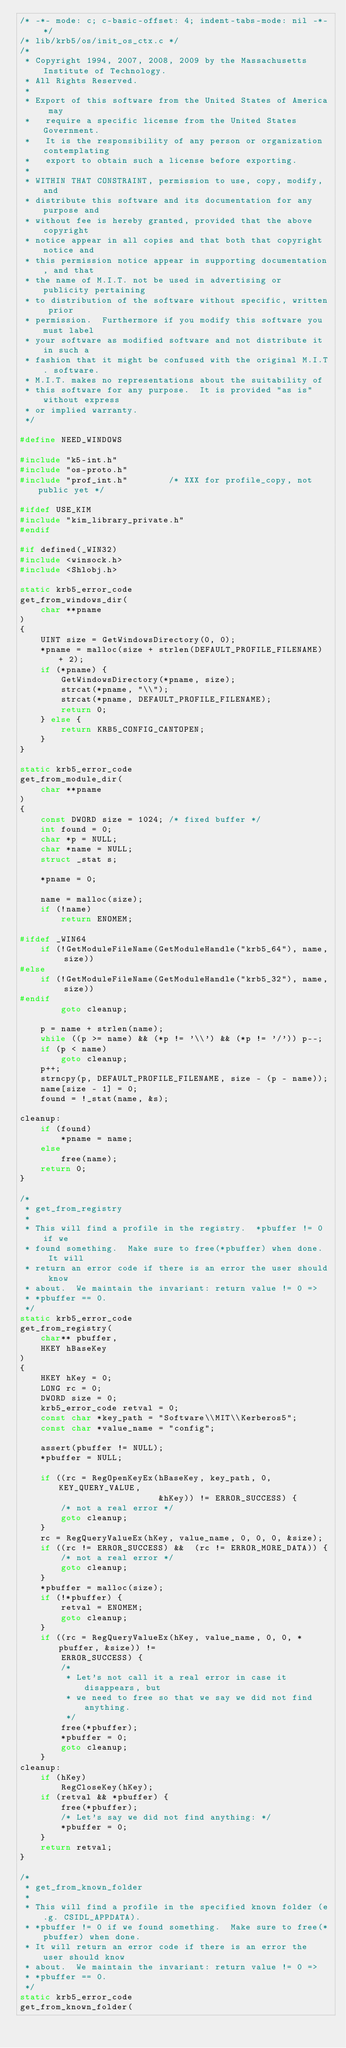Convert code to text. <code><loc_0><loc_0><loc_500><loc_500><_C_>/* -*- mode: c; c-basic-offset: 4; indent-tabs-mode: nil -*- */
/* lib/krb5/os/init_os_ctx.c */
/*
 * Copyright 1994, 2007, 2008, 2009 by the Massachusetts Institute of Technology.
 * All Rights Reserved.
 *
 * Export of this software from the United States of America may
 *   require a specific license from the United States Government.
 *   It is the responsibility of any person or organization contemplating
 *   export to obtain such a license before exporting.
 *
 * WITHIN THAT CONSTRAINT, permission to use, copy, modify, and
 * distribute this software and its documentation for any purpose and
 * without fee is hereby granted, provided that the above copyright
 * notice appear in all copies and that both that copyright notice and
 * this permission notice appear in supporting documentation, and that
 * the name of M.I.T. not be used in advertising or publicity pertaining
 * to distribution of the software without specific, written prior
 * permission.  Furthermore if you modify this software you must label
 * your software as modified software and not distribute it in such a
 * fashion that it might be confused with the original M.I.T. software.
 * M.I.T. makes no representations about the suitability of
 * this software for any purpose.  It is provided "as is" without express
 * or implied warranty.
 */

#define NEED_WINDOWS

#include "k5-int.h"
#include "os-proto.h"
#include "prof_int.h"        /* XXX for profile_copy, not public yet */

#ifdef USE_KIM
#include "kim_library_private.h"
#endif

#if defined(_WIN32)
#include <winsock.h>
#include <Shlobj.h>

static krb5_error_code
get_from_windows_dir(
    char **pname
)
{
    UINT size = GetWindowsDirectory(0, 0);
    *pname = malloc(size + strlen(DEFAULT_PROFILE_FILENAME) + 2);
    if (*pname) {
        GetWindowsDirectory(*pname, size);
        strcat(*pname, "\\");
        strcat(*pname, DEFAULT_PROFILE_FILENAME);
        return 0;
    } else {
        return KRB5_CONFIG_CANTOPEN;
    }
}

static krb5_error_code
get_from_module_dir(
    char **pname
)
{
    const DWORD size = 1024; /* fixed buffer */
    int found = 0;
    char *p = NULL;
    char *name = NULL;
    struct _stat s;

    *pname = 0;

    name = malloc(size);
    if (!name)
        return ENOMEM;

#ifdef _WIN64
    if (!GetModuleFileName(GetModuleHandle("krb5_64"), name, size))
#else
    if (!GetModuleFileName(GetModuleHandle("krb5_32"), name, size))
#endif
        goto cleanup;

    p = name + strlen(name);
    while ((p >= name) && (*p != '\\') && (*p != '/')) p--;
    if (p < name)
        goto cleanup;
    p++;
    strncpy(p, DEFAULT_PROFILE_FILENAME, size - (p - name));
    name[size - 1] = 0;
    found = !_stat(name, &s);

cleanup:
    if (found)
        *pname = name;
    else
        free(name);
    return 0;
}

/*
 * get_from_registry
 *
 * This will find a profile in the registry.  *pbuffer != 0 if we
 * found something.  Make sure to free(*pbuffer) when done.  It will
 * return an error code if there is an error the user should know
 * about.  We maintain the invariant: return value != 0 =>
 * *pbuffer == 0.
 */
static krb5_error_code
get_from_registry(
    char** pbuffer,
    HKEY hBaseKey
)
{
    HKEY hKey = 0;
    LONG rc = 0;
    DWORD size = 0;
    krb5_error_code retval = 0;
    const char *key_path = "Software\\MIT\\Kerberos5";
    const char *value_name = "config";

    assert(pbuffer != NULL);
    *pbuffer = NULL;

    if ((rc = RegOpenKeyEx(hBaseKey, key_path, 0, KEY_QUERY_VALUE,
                           &hKey)) != ERROR_SUCCESS) {
        /* not a real error */
        goto cleanup;
    }
    rc = RegQueryValueEx(hKey, value_name, 0, 0, 0, &size);
    if ((rc != ERROR_SUCCESS) &&  (rc != ERROR_MORE_DATA)) {
        /* not a real error */
        goto cleanup;
    }
    *pbuffer = malloc(size);
    if (!*pbuffer) {
        retval = ENOMEM;
        goto cleanup;
    }
    if ((rc = RegQueryValueEx(hKey, value_name, 0, 0, *pbuffer, &size)) !=
        ERROR_SUCCESS) {
        /*
         * Let's not call it a real error in case it disappears, but
         * we need to free so that we say we did not find anything.
         */
        free(*pbuffer);
        *pbuffer = 0;
        goto cleanup;
    }
cleanup:
    if (hKey)
        RegCloseKey(hKey);
    if (retval && *pbuffer) {
        free(*pbuffer);
        /* Let's say we did not find anything: */
        *pbuffer = 0;
    }
    return retval;
}

/*
 * get_from_known_folder
 *
 * This will find a profile in the specified known folder (e.g. CSIDL_APPDATA).
 * *pbuffer != 0 if we found something.  Make sure to free(*pbuffer) when done.
 * It will return an error code if there is an error the user should know
 * about.  We maintain the invariant: return value != 0 =>
 * *pbuffer == 0.
 */
static krb5_error_code
get_from_known_folder(</code> 